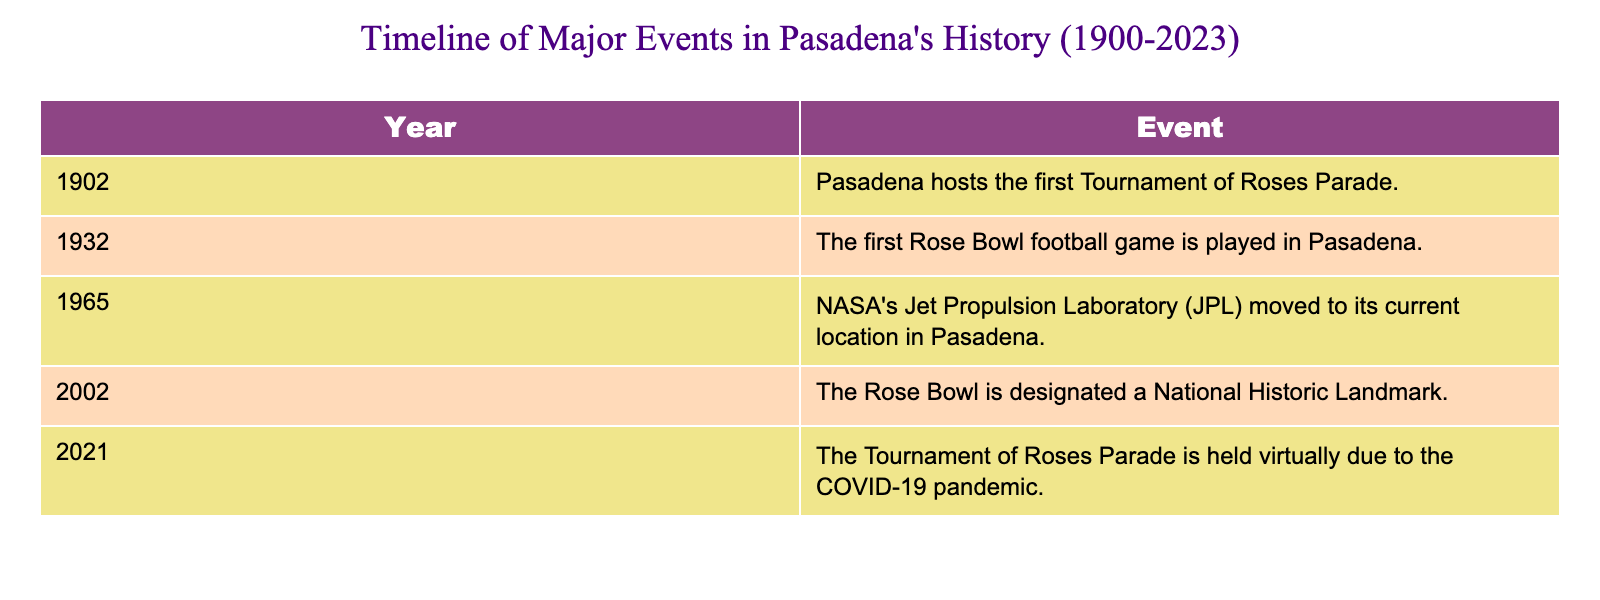What year did Pasadena host the first Tournament of Roses Parade? The table lists the year 1902 associated with the first Tournament of Roses Parade.
Answer: 1902 What historic designation was given to the Rose Bowl in 2002? The table indicates that in 2002, the Rose Bowl was designated a National Historic Landmark.
Answer: National Historic Landmark How many major events in Pasadena's history are listed in the table? There are a total of five events listed from the years 1902 to 2021.
Answer: 5 Which event marks the beginning of the Rose Bowl tradition in Pasadena? The table shows that the first Rose Bowl football game was played in 1932, marking the beginning of this tradition.
Answer: First Rose Bowl football game in 1932 Is it true that Pasadena's Jet Propulsion Laboratory moved there before 1970? According to the table, the Jet Propulsion Laboratory moved to Pasadena in 1965, which is before 1970.
Answer: True How many years passed between the first Tournament of Roses Parade and the first Rose Bowl football game? The first Tournament of Roses Parade occurred in 1902 and the first Rose Bowl football game happened in 1932. The time elapsed is 1932 - 1902 = 30 years.
Answer: 30 years What is the distinction of the Rose Bowl mentioned in the table for the year 2002? The table notes that in 2002, the Rose Bowl was designated a National Historic Landmark, which signifies its historical importance.
Answer: National Historic Landmark What was unique about the Tournament of Roses Parade in 2021? The table mentions that the Tournament of Roses Parade was held virtually in 2021 due to the COVID-19 pandemic.
Answer: Held virtually due to COVID-19 Between which two events did NASA's Jet Propulsion Laboratory move to Pasadena? NASA's Jet Propulsion Laboratory moved in 1965 and the first Rose Bowl event was in 1932. So, the events surrounding the move are the first Rose Bowl in 1932 and the designation of the Rose Bowl in 2002.
Answer: First Rose Bowl (1932) and Rose Bowl National Historic Landmark (2002) How many events listed were related to the Rose Bowl? The table contains three events related to the Rose Bowl: the first Tournament of Roses Parade in 1902, the first Rose Bowl football game in 1932, and the Rose Bowl’s designation as a National Historic Landmark in 2002.
Answer: 3 